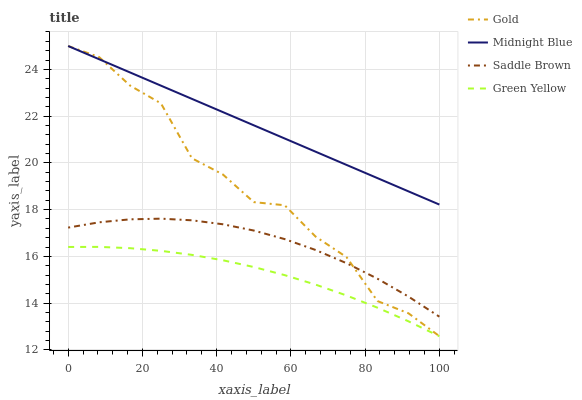Does Green Yellow have the minimum area under the curve?
Answer yes or no. Yes. Does Midnight Blue have the maximum area under the curve?
Answer yes or no. Yes. Does Gold have the minimum area under the curve?
Answer yes or no. No. Does Gold have the maximum area under the curve?
Answer yes or no. No. Is Midnight Blue the smoothest?
Answer yes or no. Yes. Is Gold the roughest?
Answer yes or no. Yes. Is Gold the smoothest?
Answer yes or no. No. Is Midnight Blue the roughest?
Answer yes or no. No. Does Gold have the lowest value?
Answer yes or no. No. Does Saddle Brown have the highest value?
Answer yes or no. No. Is Green Yellow less than Gold?
Answer yes or no. Yes. Is Gold greater than Green Yellow?
Answer yes or no. Yes. Does Green Yellow intersect Gold?
Answer yes or no. No. 